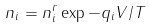Convert formula to latex. <formula><loc_0><loc_0><loc_500><loc_500>n _ { i } = n _ { i } ^ { r } \exp { - q _ { i } V / T }</formula> 